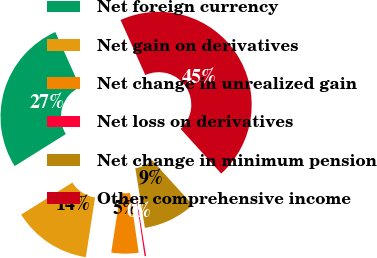Convert chart to OTSL. <chart><loc_0><loc_0><loc_500><loc_500><pie_chart><fcel>Net foreign currency<fcel>Net gain on derivatives<fcel>Net change in unrealized gain<fcel>Net loss on derivatives<fcel>Net change in minimum pension<fcel>Other comprehensive income<nl><fcel>27.16%<fcel>13.67%<fcel>4.72%<fcel>0.25%<fcel>9.2%<fcel>45.0%<nl></chart> 